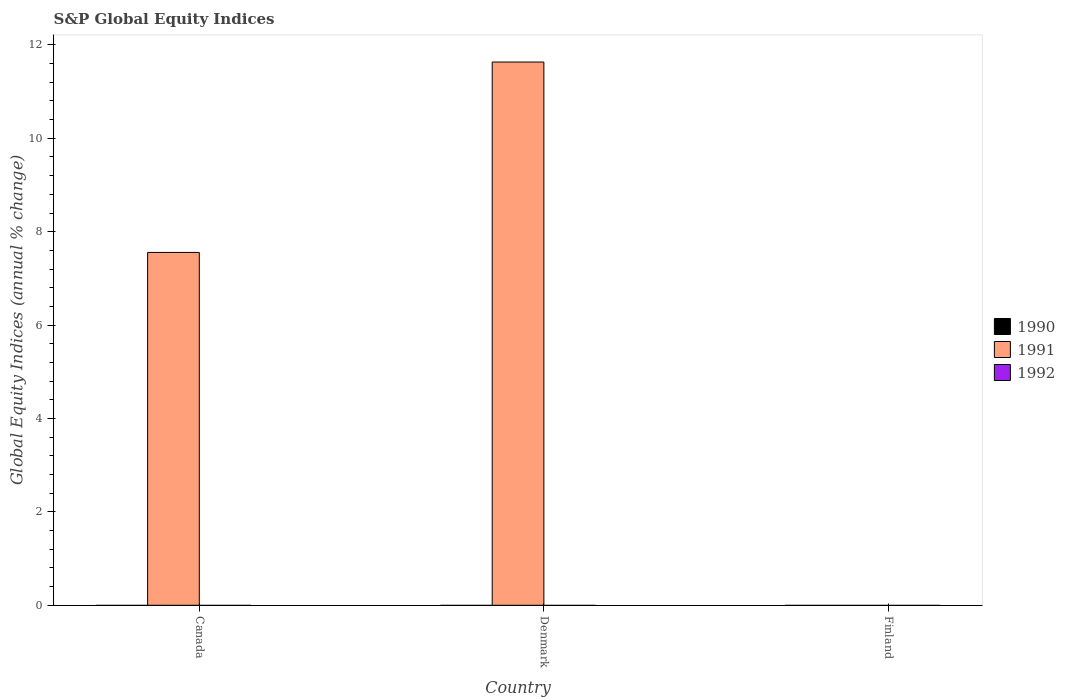Are the number of bars on each tick of the X-axis equal?
Offer a terse response. No. How many bars are there on the 2nd tick from the left?
Your answer should be compact. 1. How many bars are there on the 1st tick from the right?
Ensure brevity in your answer.  0. In how many cases, is the number of bars for a given country not equal to the number of legend labels?
Your response must be concise. 3. What is the global equity indices in 1992 in Canada?
Offer a very short reply. 0. Across all countries, what is the maximum global equity indices in 1991?
Offer a terse response. 11.63. Across all countries, what is the minimum global equity indices in 1992?
Ensure brevity in your answer.  0. What is the total global equity indices in 1990 in the graph?
Make the answer very short. 0. What is the average global equity indices in 1991 per country?
Give a very brief answer. 6.4. What is the ratio of the global equity indices in 1991 in Canada to that in Denmark?
Your response must be concise. 0.65. Is it the case that in every country, the sum of the global equity indices in 1990 and global equity indices in 1991 is greater than the global equity indices in 1992?
Offer a terse response. No. Are all the bars in the graph horizontal?
Offer a terse response. No. How many countries are there in the graph?
Your answer should be compact. 3. Are the values on the major ticks of Y-axis written in scientific E-notation?
Give a very brief answer. No. Where does the legend appear in the graph?
Offer a very short reply. Center right. How are the legend labels stacked?
Provide a succinct answer. Vertical. What is the title of the graph?
Provide a short and direct response. S&P Global Equity Indices. Does "1996" appear as one of the legend labels in the graph?
Make the answer very short. No. What is the label or title of the X-axis?
Give a very brief answer. Country. What is the label or title of the Y-axis?
Provide a short and direct response. Global Equity Indices (annual % change). What is the Global Equity Indices (annual % change) of 1990 in Canada?
Give a very brief answer. 0. What is the Global Equity Indices (annual % change) in 1991 in Canada?
Your answer should be compact. 7.56. What is the Global Equity Indices (annual % change) of 1992 in Canada?
Ensure brevity in your answer.  0. What is the Global Equity Indices (annual % change) in 1990 in Denmark?
Your answer should be compact. 0. What is the Global Equity Indices (annual % change) in 1991 in Denmark?
Your answer should be compact. 11.63. What is the Global Equity Indices (annual % change) in 1990 in Finland?
Your answer should be compact. 0. Across all countries, what is the maximum Global Equity Indices (annual % change) in 1991?
Your response must be concise. 11.63. What is the total Global Equity Indices (annual % change) of 1991 in the graph?
Ensure brevity in your answer.  19.19. What is the difference between the Global Equity Indices (annual % change) in 1991 in Canada and that in Denmark?
Offer a terse response. -4.08. What is the average Global Equity Indices (annual % change) of 1990 per country?
Your answer should be compact. 0. What is the average Global Equity Indices (annual % change) of 1991 per country?
Make the answer very short. 6.4. What is the average Global Equity Indices (annual % change) in 1992 per country?
Offer a terse response. 0. What is the ratio of the Global Equity Indices (annual % change) in 1991 in Canada to that in Denmark?
Offer a terse response. 0.65. What is the difference between the highest and the lowest Global Equity Indices (annual % change) of 1991?
Your answer should be very brief. 11.63. 